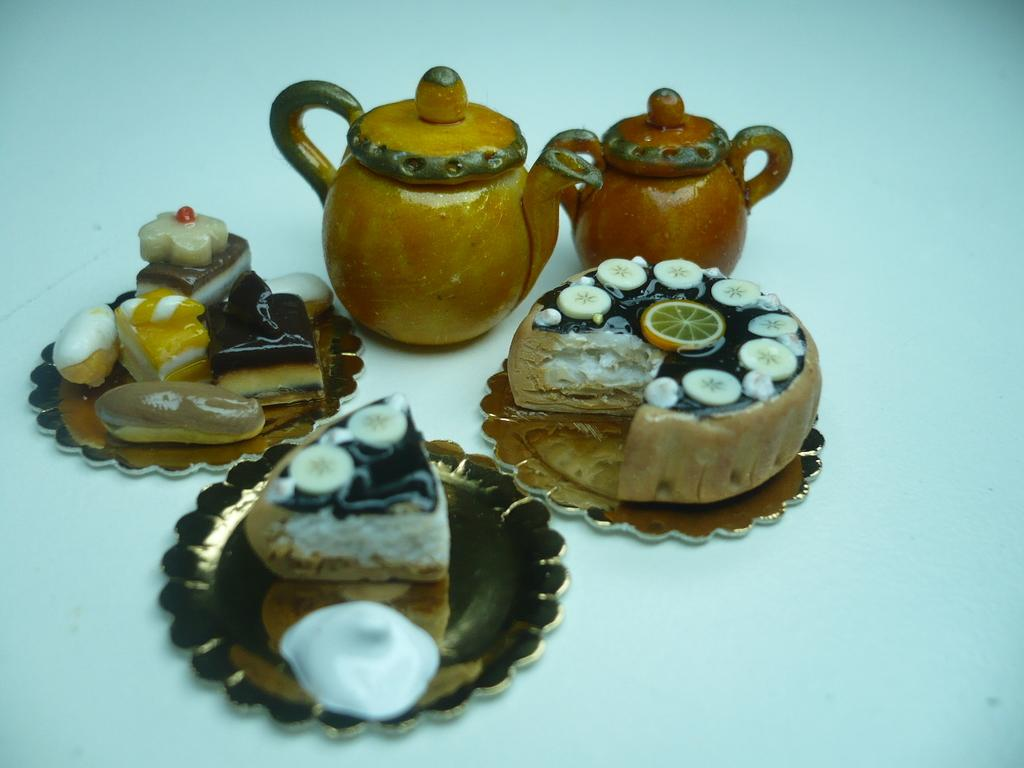What can be seen on the plates in the image? There are food items on plates in the image. What else is present on the white surface in the image? There are teapots on a white surface in the image. What type of fear is depicted in the image? There is no fear depicted in the image; it features food items on plates and teapots on a white surface. How many suits are visible in the image? There are no suits present in the image. 